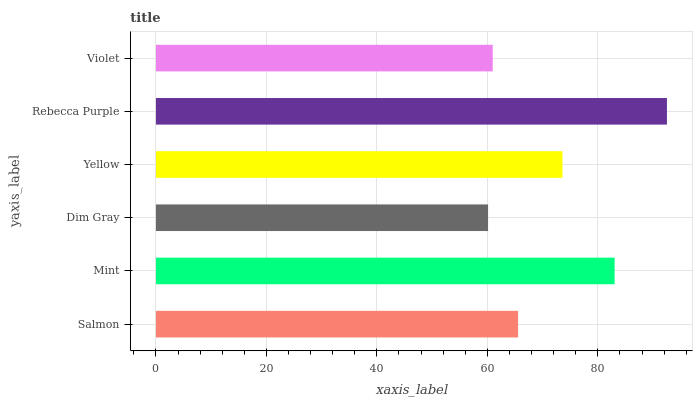Is Dim Gray the minimum?
Answer yes or no. Yes. Is Rebecca Purple the maximum?
Answer yes or no. Yes. Is Mint the minimum?
Answer yes or no. No. Is Mint the maximum?
Answer yes or no. No. Is Mint greater than Salmon?
Answer yes or no. Yes. Is Salmon less than Mint?
Answer yes or no. Yes. Is Salmon greater than Mint?
Answer yes or no. No. Is Mint less than Salmon?
Answer yes or no. No. Is Yellow the high median?
Answer yes or no. Yes. Is Salmon the low median?
Answer yes or no. Yes. Is Dim Gray the high median?
Answer yes or no. No. Is Yellow the low median?
Answer yes or no. No. 